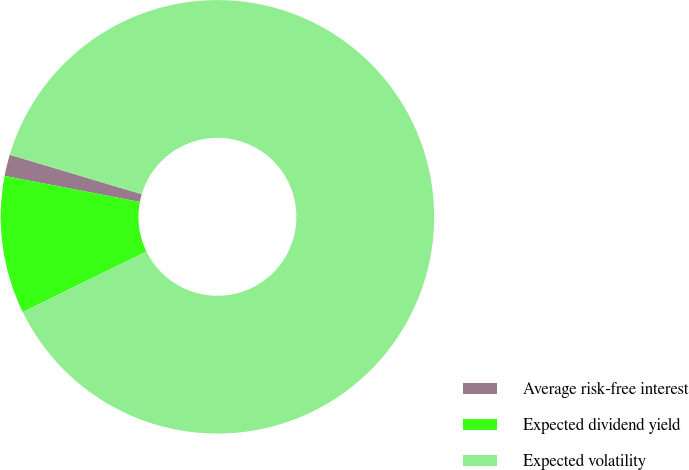<chart> <loc_0><loc_0><loc_500><loc_500><pie_chart><fcel>Average risk-free interest<fcel>Expected dividend yield<fcel>Expected volatility<nl><fcel>1.6%<fcel>10.26%<fcel>88.14%<nl></chart> 